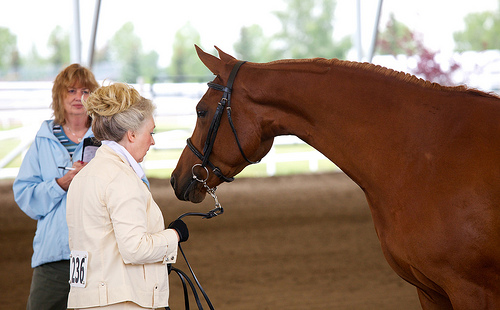<image>
Is there a bun to the left of the horse? Yes. From this viewpoint, the bun is positioned to the left side relative to the horse. Is there a horse behind the woman? No. The horse is not behind the woman. From this viewpoint, the horse appears to be positioned elsewhere in the scene. 